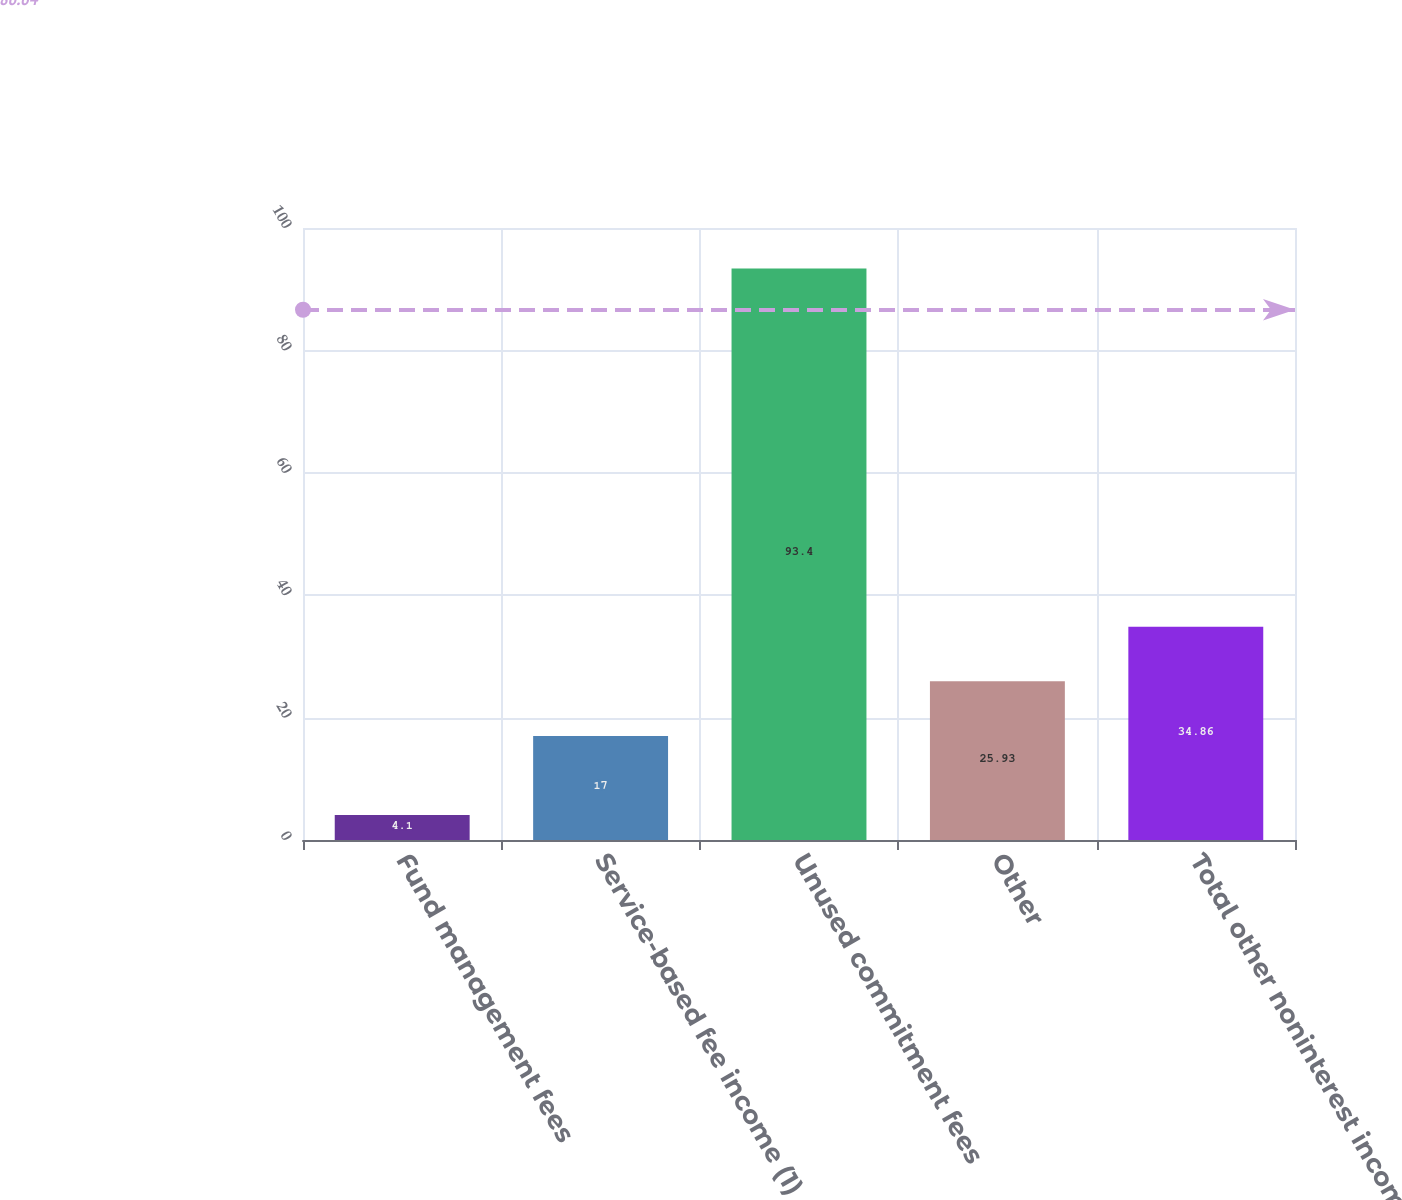Convert chart. <chart><loc_0><loc_0><loc_500><loc_500><bar_chart><fcel>Fund management fees<fcel>Service-based fee income (1)<fcel>Unused commitment fees<fcel>Other<fcel>Total other noninterest income<nl><fcel>4.1<fcel>17<fcel>93.4<fcel>25.93<fcel>34.86<nl></chart> 